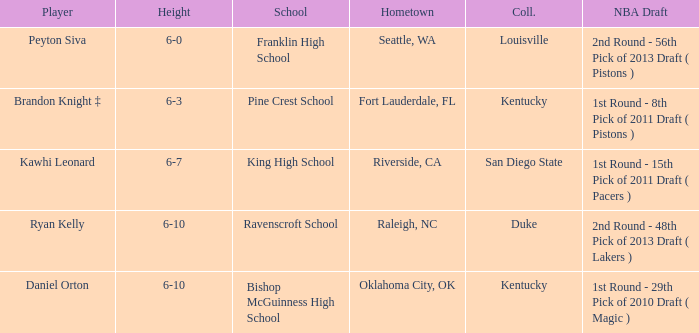Which college does Peyton Siva play for? Louisville. 